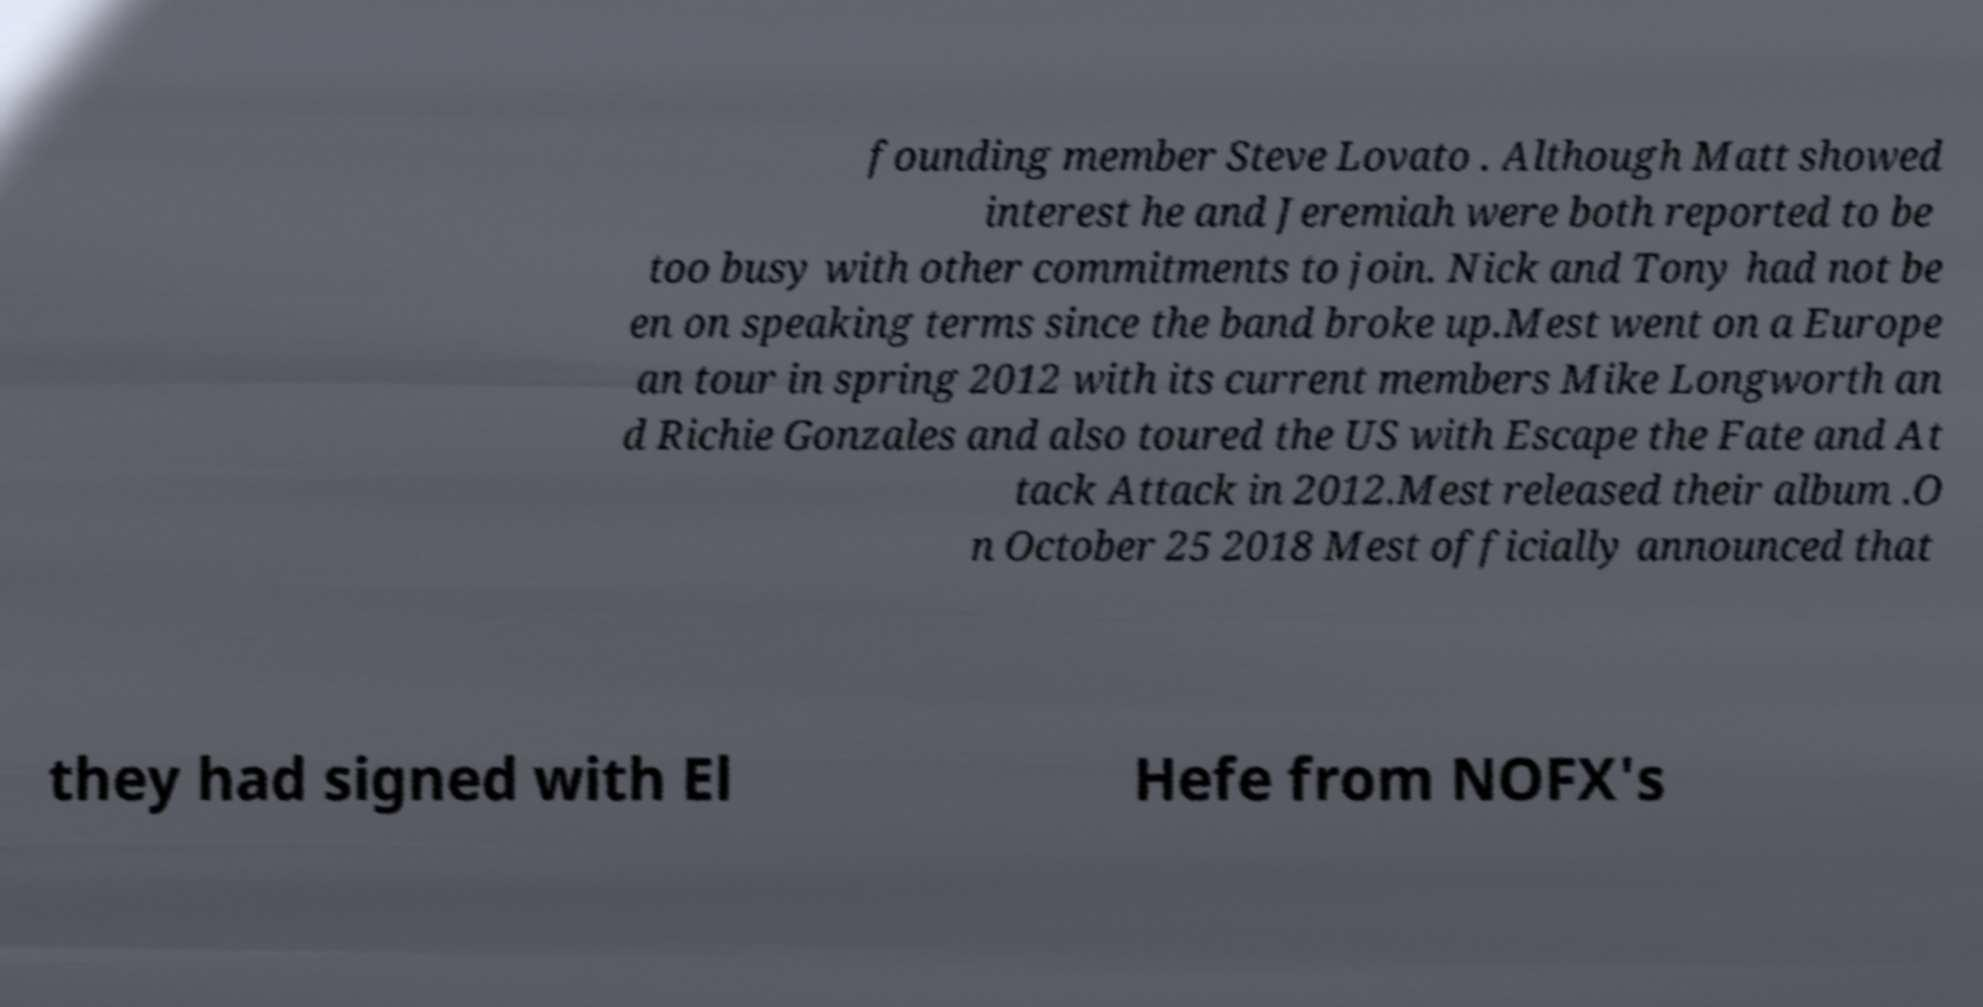Can you accurately transcribe the text from the provided image for me? founding member Steve Lovato . Although Matt showed interest he and Jeremiah were both reported to be too busy with other commitments to join. Nick and Tony had not be en on speaking terms since the band broke up.Mest went on a Europe an tour in spring 2012 with its current members Mike Longworth an d Richie Gonzales and also toured the US with Escape the Fate and At tack Attack in 2012.Mest released their album .O n October 25 2018 Mest officially announced that they had signed with El Hefe from NOFX's 